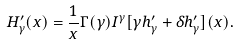Convert formula to latex. <formula><loc_0><loc_0><loc_500><loc_500>H _ { \gamma } ^ { \prime } ( x ) = \frac { 1 } { x } \Gamma ( \gamma ) I ^ { \gamma } [ \gamma h _ { \gamma } ^ { \prime } + \delta h _ { \gamma } ^ { \prime } ] ( x ) .</formula> 